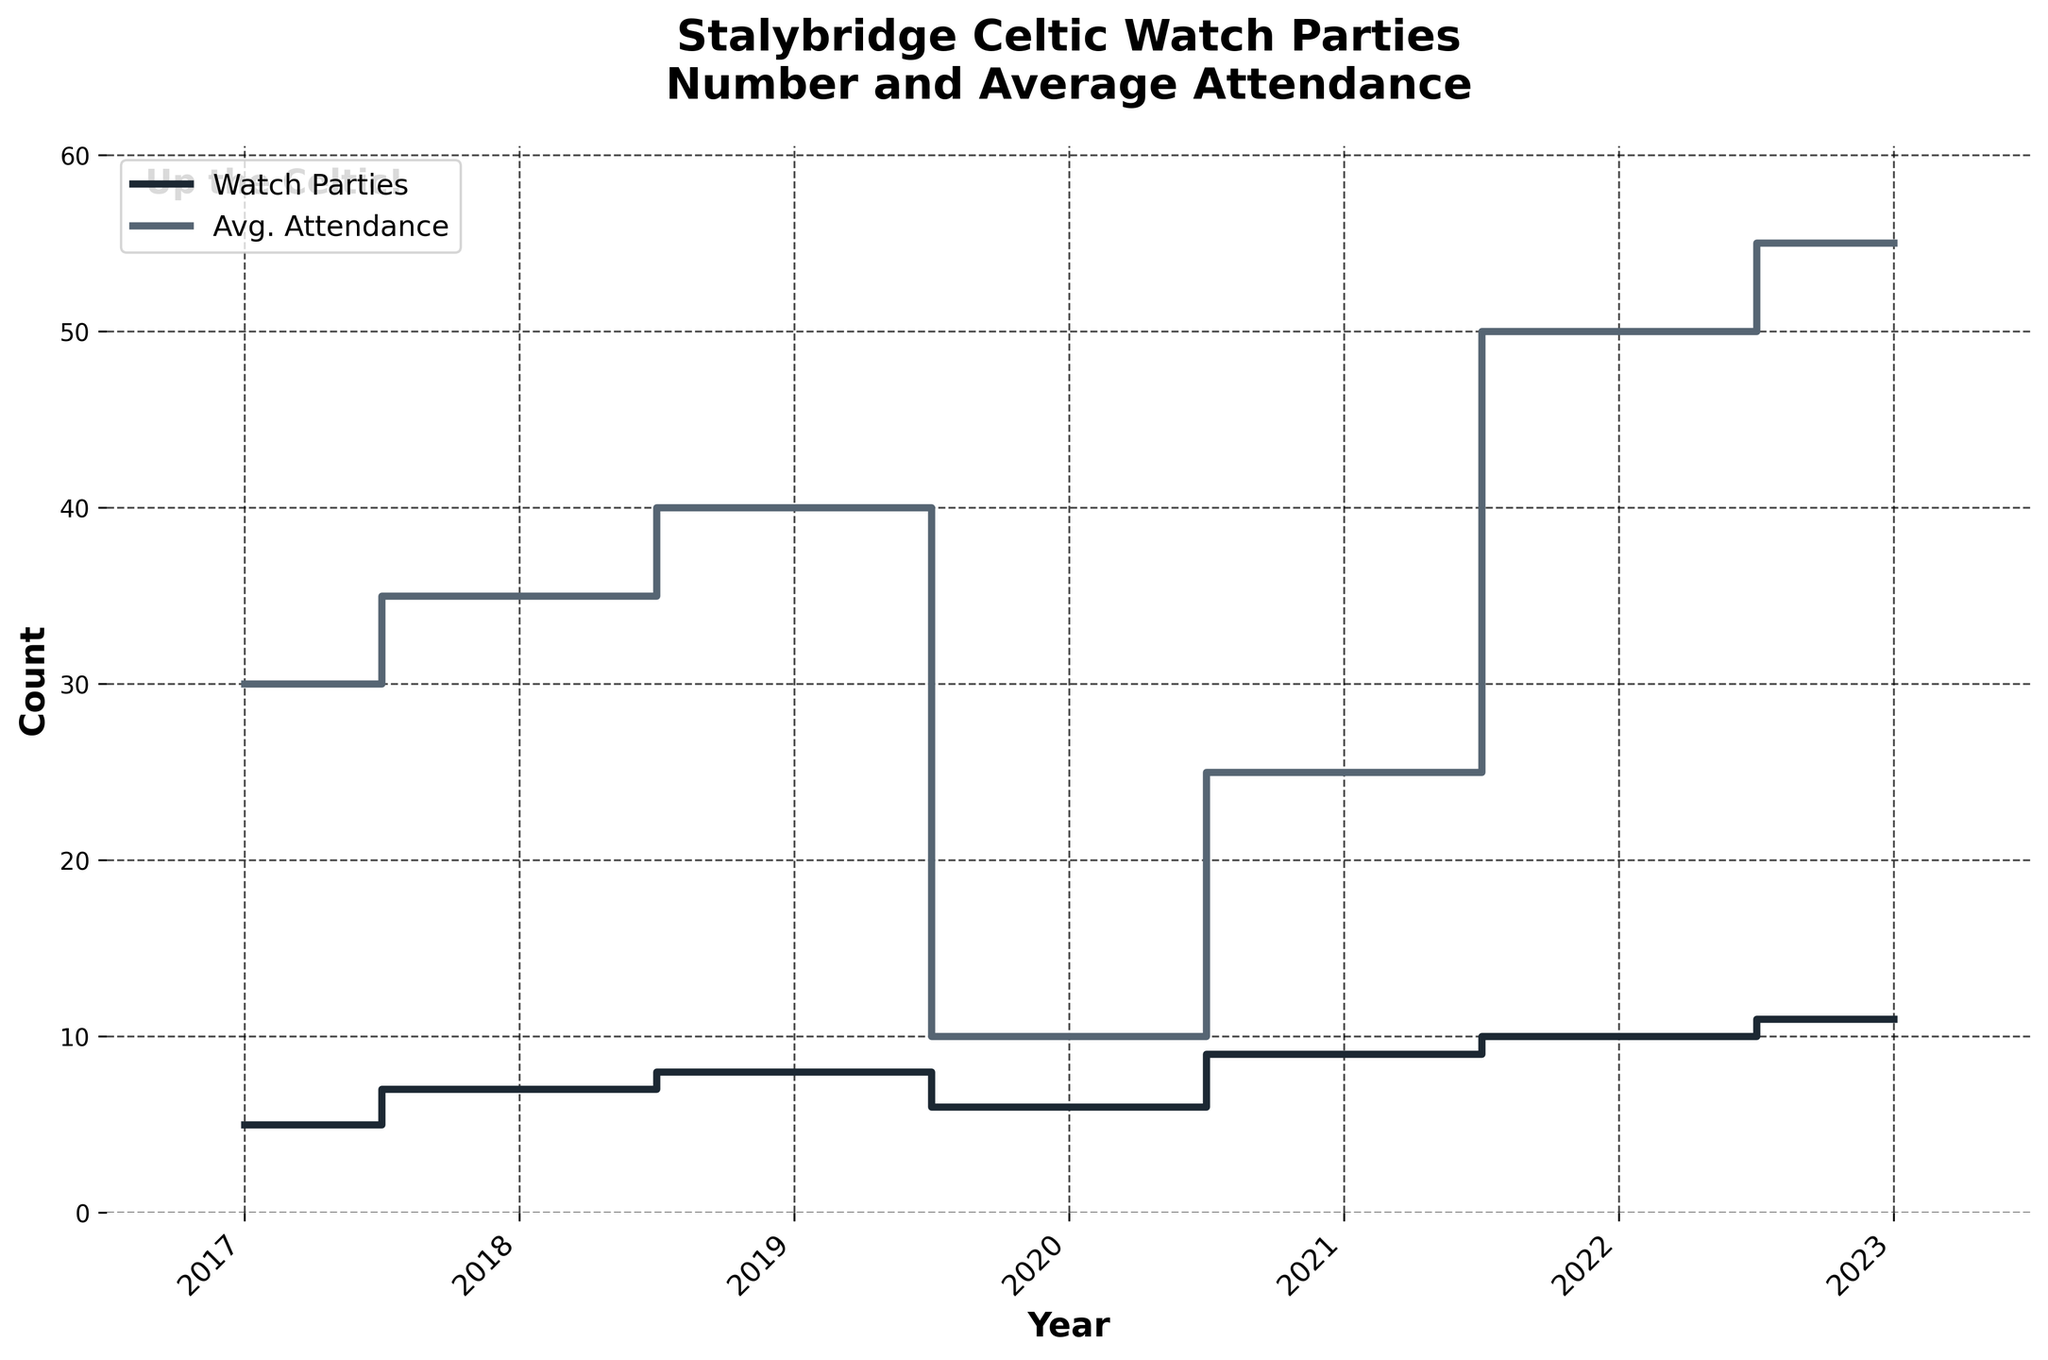What's the title of the plot? The title is located at the top center of the figure, and it should be easily readable.
Answer: Stalybridge Celtic Watch Parties What does the y-axis represent? The y-axis label is found on the vertical axis of the plot.
Answer: Count How many watch parties were organized in 2017? Look at the step line representing the number of watch parties and check the value for the year 2017.
Answer: 5 In which year did the average attendance peak? Observe the line representing average attendance and identify the highest point on the plot.
Answer: 2023 How did the number of watch parties change from 2019 to 2020? Compare the values of the number of watch parties in 2019 and 2020.
Answer: Decreased by 2 What's the difference in average attendance between 2020 and 2021? Subtract the average attendance of 2020 from that of 2021.
Answer: 15 Which year had the lowest average attendance? Identify the lowest point on the average attendance line to find the corresponding year.
Answer: 2020 Did the number of watch parties increase consistently every year? Check the number of watch parties for each year to see if there is a consistent increase.
Answer: No In which years did both the number of watch parties and average attendance increase? Compare each year to see in which both parameters under consideration showed an increase.
Answer: 2017 to 2018, 2021 to 2022, 2022 to 2023 Is there any year where the average attendance was exactly double the number of watch parties? Compare the corresponding values of average attendance and the number of watch parties across different years. Calculate where the average attendance is twice the number of watch parties.
Answer: 2022 